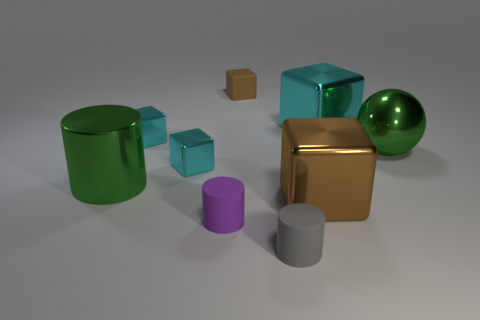How many cyan blocks must be subtracted to get 1 cyan blocks? 2 Subtract all cyan spheres. How many cyan cubes are left? 3 Subtract all green cylinders. How many cylinders are left? 2 Subtract all brown cubes. How many cubes are left? 3 Subtract all yellow cubes. Subtract all yellow spheres. How many cubes are left? 5 Subtract 0 green cubes. How many objects are left? 9 Subtract all cubes. How many objects are left? 4 Subtract all gray matte balls. Subtract all metallic cubes. How many objects are left? 5 Add 1 big blocks. How many big blocks are left? 3 Add 2 big cyan blocks. How many big cyan blocks exist? 3 